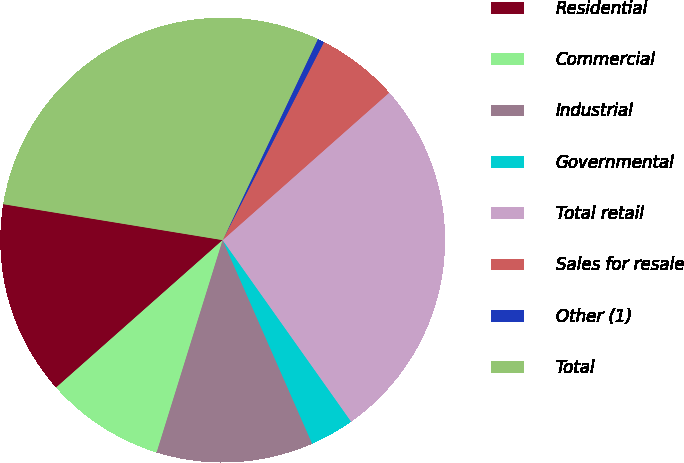Convert chart. <chart><loc_0><loc_0><loc_500><loc_500><pie_chart><fcel>Residential<fcel>Commercial<fcel>Industrial<fcel>Governmental<fcel>Total retail<fcel>Sales for resale<fcel>Other (1)<fcel>Total<nl><fcel>14.12%<fcel>8.67%<fcel>11.39%<fcel>3.21%<fcel>26.73%<fcel>5.94%<fcel>0.49%<fcel>29.45%<nl></chart> 